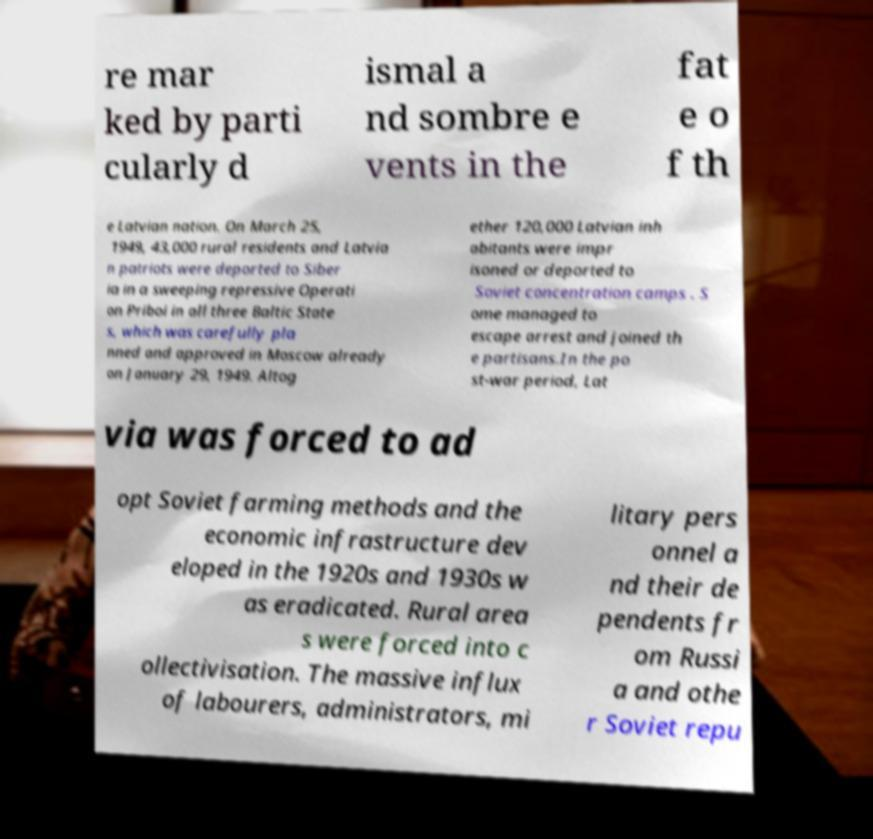What messages or text are displayed in this image? I need them in a readable, typed format. re mar ked by parti cularly d ismal a nd sombre e vents in the fat e o f th e Latvian nation. On March 25, 1949, 43,000 rural residents and Latvia n patriots were deported to Siber ia in a sweeping repressive Operati on Priboi in all three Baltic State s, which was carefully pla nned and approved in Moscow already on January 29, 1949. Altog ether 120,000 Latvian inh abitants were impr isoned or deported to Soviet concentration camps . S ome managed to escape arrest and joined th e partisans.In the po st-war period, Lat via was forced to ad opt Soviet farming methods and the economic infrastructure dev eloped in the 1920s and 1930s w as eradicated. Rural area s were forced into c ollectivisation. The massive influx of labourers, administrators, mi litary pers onnel a nd their de pendents fr om Russi a and othe r Soviet repu 